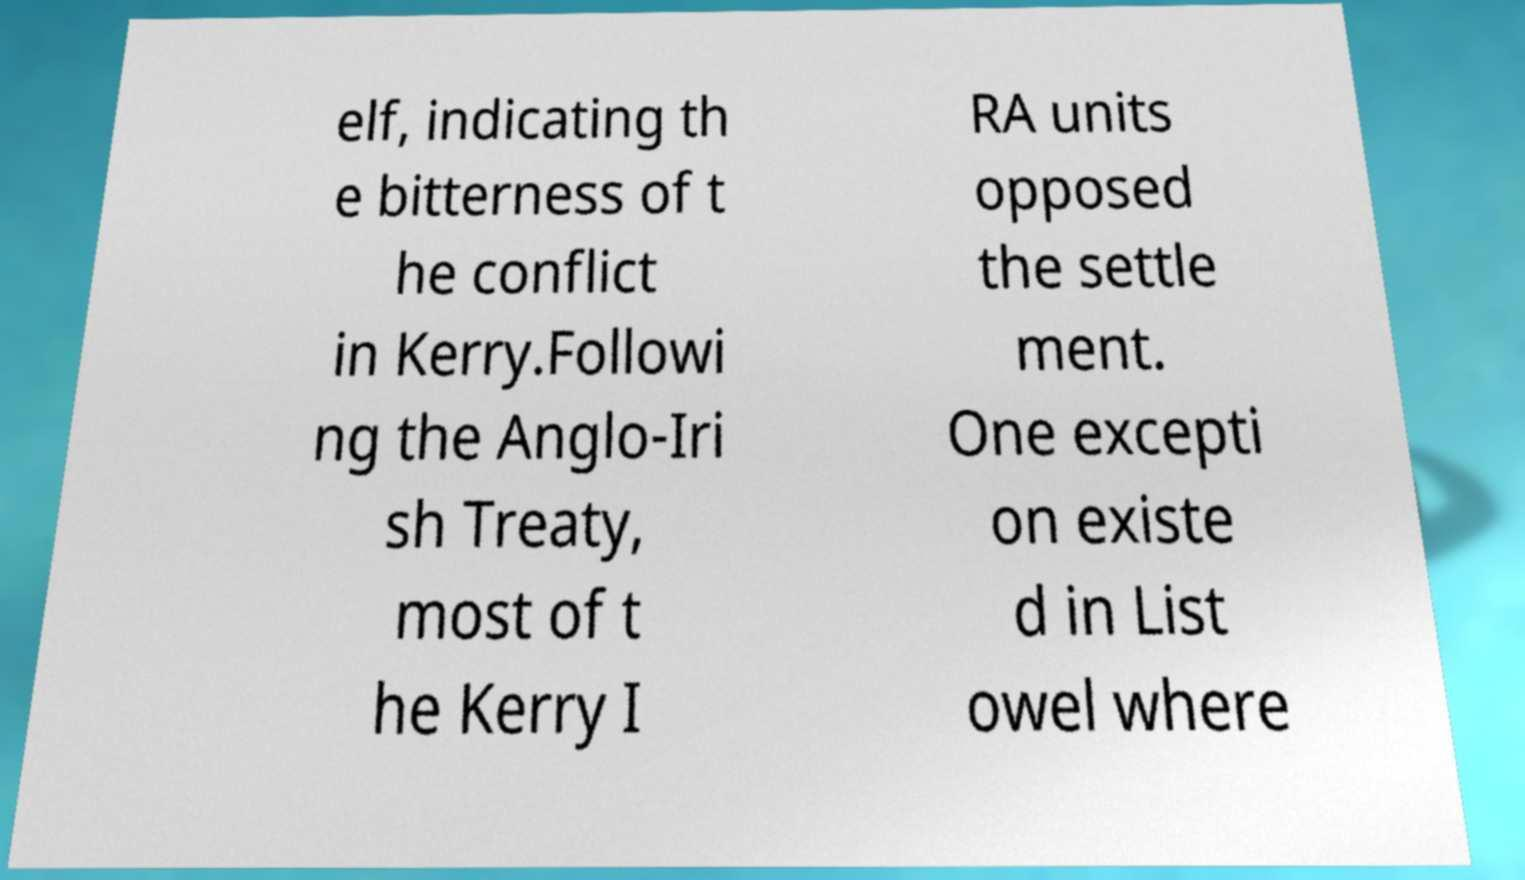There's text embedded in this image that I need extracted. Can you transcribe it verbatim? elf, indicating th e bitterness of t he conflict in Kerry.Followi ng the Anglo-Iri sh Treaty, most of t he Kerry I RA units opposed the settle ment. One excepti on existe d in List owel where 